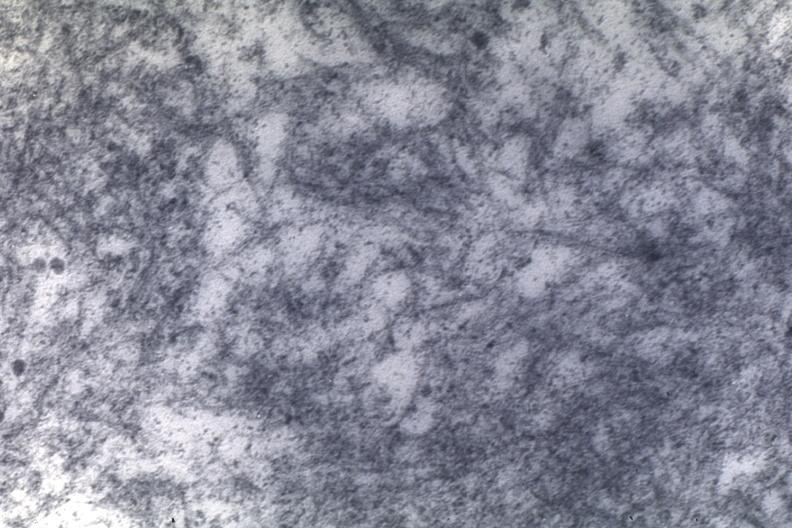s cardiovascular present?
Answer the question using a single word or phrase. Yes 